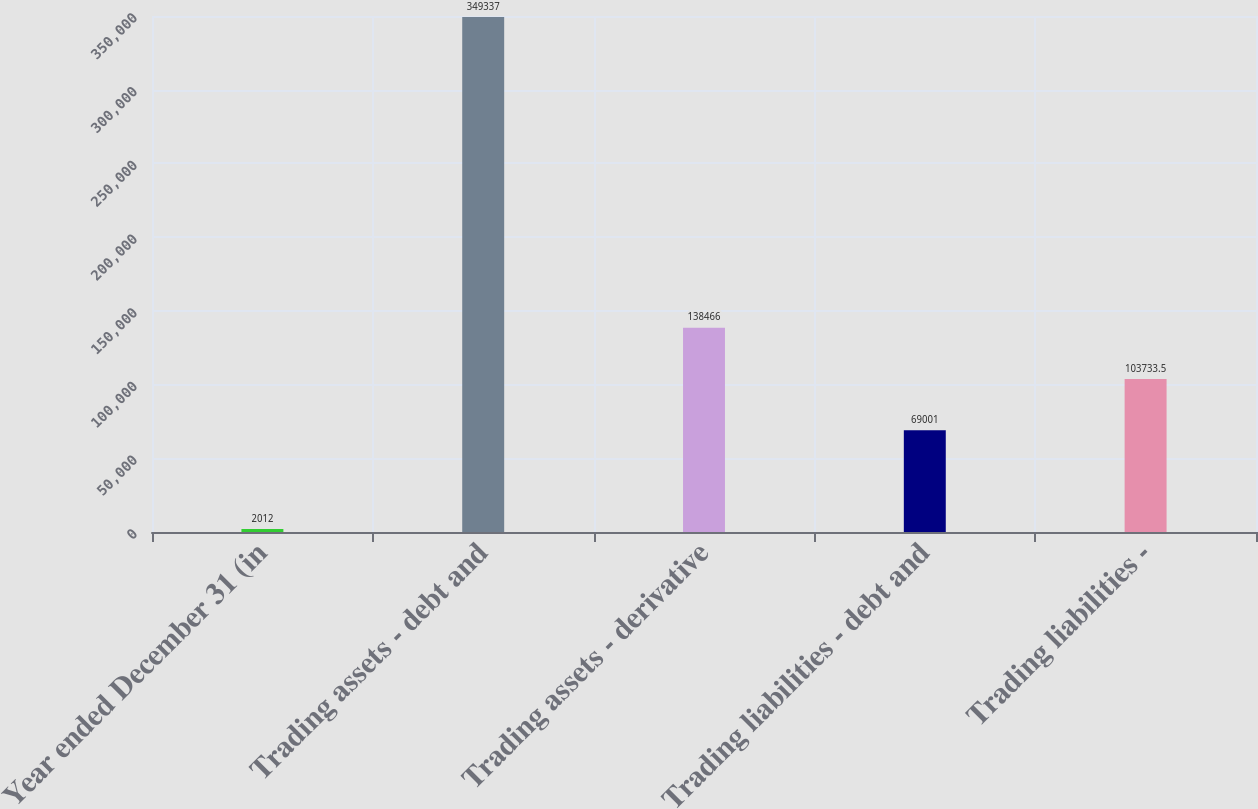<chart> <loc_0><loc_0><loc_500><loc_500><bar_chart><fcel>Year ended December 31 (in<fcel>Trading assets - debt and<fcel>Trading assets - derivative<fcel>Trading liabilities - debt and<fcel>Trading liabilities -<nl><fcel>2012<fcel>349337<fcel>138466<fcel>69001<fcel>103734<nl></chart> 